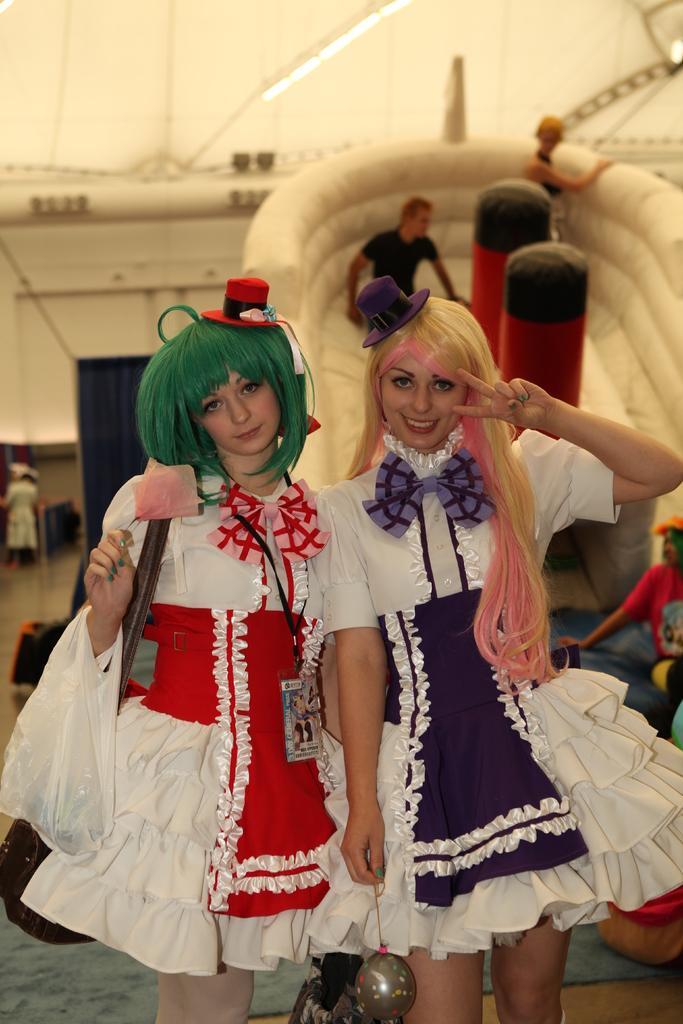In one or two sentences, can you explain what this image depicts? In the center of the image we can see two persons are standing and they are in different costumes. Among them, we can see one person is holding an object and the other person is wearing a bag. In the background, we can see a few people and a few other objects. 